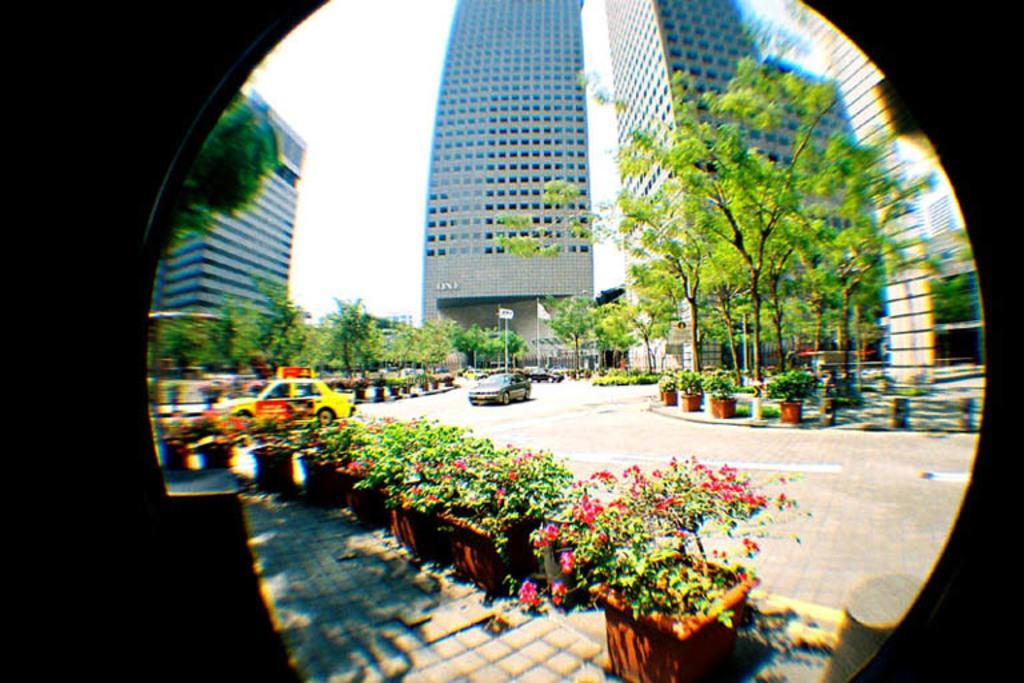What types of structures can be seen in the image? There are buildings in the image. What type of vegetation is present in the image? There are plants, trees, and flowers in the image. What is moving along the road in the image? There are vehicles on the road in the image. What can be seen flying or waving in the image? There are flags in the image. What are the tall, thin objects in the image? There are poles in the image. What part of the natural environment is visible in the image? The sky is visible in the image. What type of education is being offered in the image? There is no indication of education being offered in the image. What is the condition of the afterthought in the image? There is no afterthought present in the image. 